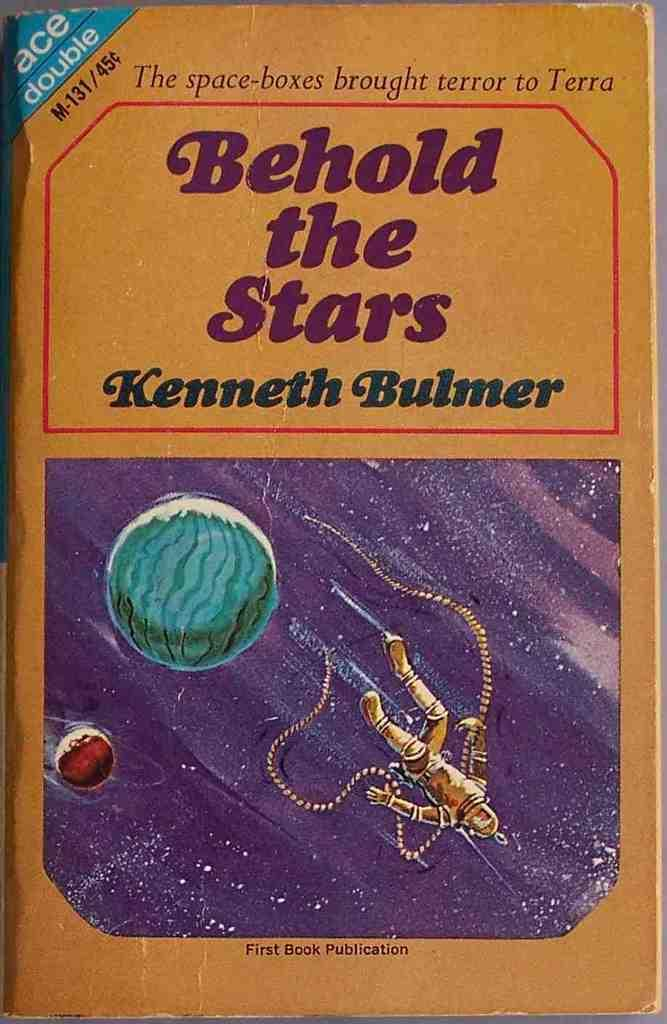<image>
Create a compact narrative representing the image presented. The book with the author name Kenneth Bulmer on it. 